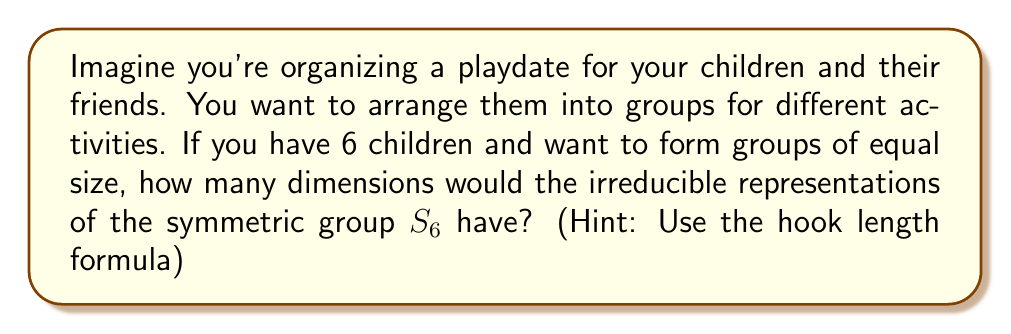What is the answer to this math problem? To solve this problem, we'll use the hook length formula for the symmetric group $S_6$. The steps are as follows:

1) First, recall that the irreducible representations of $S_n$ are in one-to-one correspondence with partitions of $n$.

2) For $S_6$, we need to consider all partitions of 6:
   $(6)$, $(5,1)$, $(4,2)$, $(4,1,1)$, $(3,3)$, $(3,2,1)$, $(3,1,1,1)$, $(2,2,2)$, $(2,2,1,1)$, $(2,1,1,1,1)$, $(1,1,1,1,1,1)$

3) For each partition, we'll use the hook length formula:

   $$\dim(\lambda) = \frac{n!}{\prod_{(i,j)\in \lambda} h_{ij}}$$

   where $h_{ij}$ is the hook length of the box $(i,j)$ in the Young diagram of $\lambda$.

4) Let's calculate for each partition:

   $(6)$: $\frac{6!}{6} = 1$
   $(5,1)$: $\frac{6!}{6\cdot1} = 5$
   $(4,2)$: $\frac{6!}{5\cdot2\cdot1} = 9$
   $(4,1,1)$: $\frac{6!}{5\cdot2\cdot1} = 10$
   $(3,3)$: $\frac{6!}{4\cdot3\cdot1} = 5$
   $(3,2,1)$: $\frac{6!}{4\cdot3\cdot2\cdot1} = 16$
   $(3,1,1,1)$: $\frac{6!}{4\cdot2\cdot1} = 10$
   $(2,2,2)$: $\frac{6!}{3\cdot2\cdot1} = 5$
   $(2,2,1,1)$: $\frac{6!}{3\cdot2\cdot2\cdot1} = 9$
   $(2,1,1,1,1)$: $\frac{6!}{3\cdot1} = 5$
   $(1,1,1,1,1,1)$: $\frac{6!}{1} = 1$

5) These are all the dimensions of the irreducible representations of $S_6$.
Answer: $1, 5, 9, 10, 5, 16, 10, 5, 9, 5, 1$ 